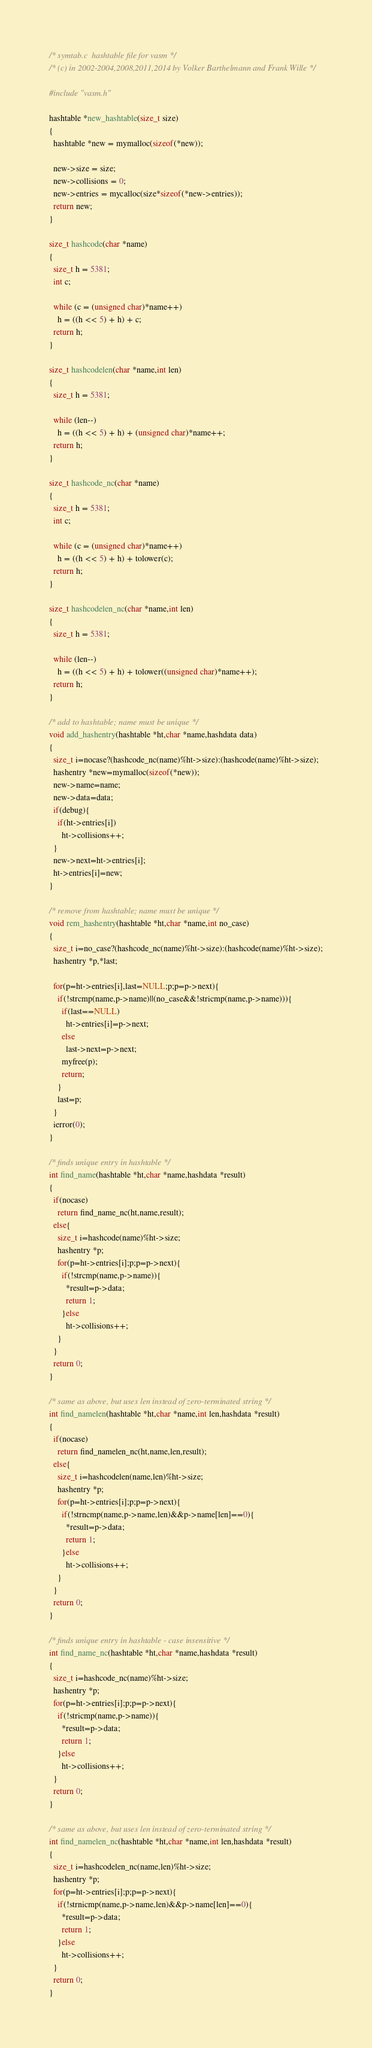Convert code to text. <code><loc_0><loc_0><loc_500><loc_500><_C_>/* symtab.c  hashtable file for vasm */
/* (c) in 2002-2004,2008,2011,2014 by Volker Barthelmann and Frank Wille */

#include "vasm.h"

hashtable *new_hashtable(size_t size)
{
  hashtable *new = mymalloc(sizeof(*new));

  new->size = size;
  new->collisions = 0;
  new->entries = mycalloc(size*sizeof(*new->entries));
  return new;
}

size_t hashcode(char *name)
{
  size_t h = 5381;
  int c;

  while (c = (unsigned char)*name++)
    h = ((h << 5) + h) + c;
  return h;
}

size_t hashcodelen(char *name,int len)
{
  size_t h = 5381;

  while (len--)
    h = ((h << 5) + h) + (unsigned char)*name++;
  return h;
}

size_t hashcode_nc(char *name)
{
  size_t h = 5381;
  int c;

  while (c = (unsigned char)*name++)
    h = ((h << 5) + h) + tolower(c);
  return h;
}

size_t hashcodelen_nc(char *name,int len)
{
  size_t h = 5381;

  while (len--)
    h = ((h << 5) + h) + tolower((unsigned char)*name++);
  return h;
}

/* add to hashtable; name must be unique */
void add_hashentry(hashtable *ht,char *name,hashdata data)
{
  size_t i=nocase?(hashcode_nc(name)%ht->size):(hashcode(name)%ht->size);
  hashentry *new=mymalloc(sizeof(*new));
  new->name=name;
  new->data=data;
  if(debug){
    if(ht->entries[i])
      ht->collisions++;
  }
  new->next=ht->entries[i];
  ht->entries[i]=new;
}

/* remove from hashtable; name must be unique */
void rem_hashentry(hashtable *ht,char *name,int no_case)
{
  size_t i=no_case?(hashcode_nc(name)%ht->size):(hashcode(name)%ht->size);
  hashentry *p,*last;

  for(p=ht->entries[i],last=NULL;p;p=p->next){
    if(!strcmp(name,p->name)||(no_case&&!stricmp(name,p->name))){
      if(last==NULL)
        ht->entries[i]=p->next;
      else
        last->next=p->next;
      myfree(p);
      return;
    }
    last=p;
  }
  ierror(0);
}

/* finds unique entry in hashtable */
int find_name(hashtable *ht,char *name,hashdata *result)
{
  if(nocase)
    return find_name_nc(ht,name,result);
  else{
    size_t i=hashcode(name)%ht->size;
    hashentry *p;
    for(p=ht->entries[i];p;p=p->next){
      if(!strcmp(name,p->name)){
        *result=p->data;
        return 1;
      }else
        ht->collisions++;
    }
  }
  return 0;
}

/* same as above, but uses len instead of zero-terminated string */
int find_namelen(hashtable *ht,char *name,int len,hashdata *result)
{
  if(nocase)
    return find_namelen_nc(ht,name,len,result);
  else{
    size_t i=hashcodelen(name,len)%ht->size;
    hashentry *p;
    for(p=ht->entries[i];p;p=p->next){
      if(!strncmp(name,p->name,len)&&p->name[len]==0){
        *result=p->data;
        return 1;
      }else
        ht->collisions++;
    }
  }
  return 0;
}

/* finds unique entry in hashtable - case insensitive */
int find_name_nc(hashtable *ht,char *name,hashdata *result)
{
  size_t i=hashcode_nc(name)%ht->size;
  hashentry *p;
  for(p=ht->entries[i];p;p=p->next){
    if(!stricmp(name,p->name)){
      *result=p->data;
      return 1;
    }else
      ht->collisions++;
  }
  return 0;
}

/* same as above, but uses len instead of zero-terminated string */
int find_namelen_nc(hashtable *ht,char *name,int len,hashdata *result)
{
  size_t i=hashcodelen_nc(name,len)%ht->size;
  hashentry *p;
  for(p=ht->entries[i];p;p=p->next){
    if(!strnicmp(name,p->name,len)&&p->name[len]==0){
      *result=p->data;
      return 1;
    }else
      ht->collisions++;
  }
  return 0;
}
</code> 